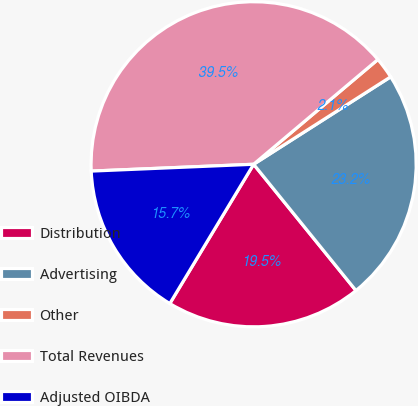Convert chart. <chart><loc_0><loc_0><loc_500><loc_500><pie_chart><fcel>Distribution<fcel>Advertising<fcel>Other<fcel>Total Revenues<fcel>Adjusted OIBDA<nl><fcel>19.46%<fcel>23.2%<fcel>2.11%<fcel>39.52%<fcel>15.71%<nl></chart> 